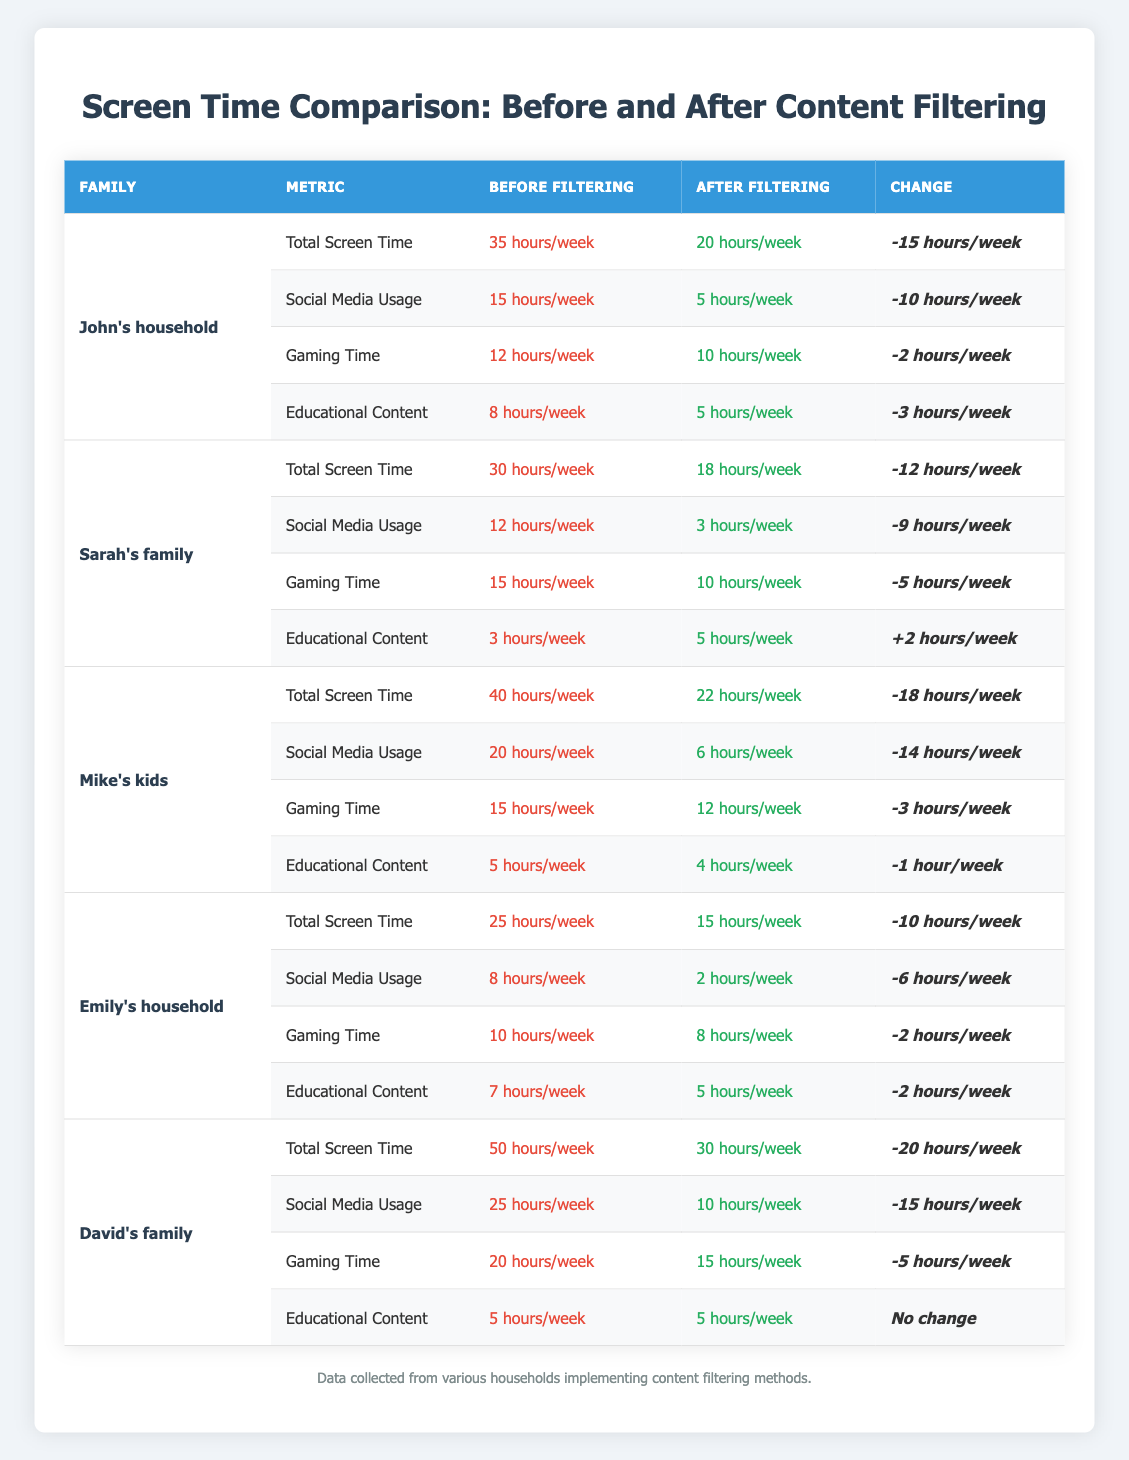What was the total screen time for John's household before filtering? The table shows that John's household had a total screen time of 35 hours per week before filtering.
Answer: 35 hours/week How many hours did Sarah's family reduce in social media usage after filtering? Sarah's family reduced their social media usage from 12 hours per week to 3 hours per week, which is a reduction of 12 - 3 = 9 hours.
Answer: 9 hours/week Which household had the highest total screen time after filtering? After filtering, David's family had 30 hours of total screen time, which is the highest compared to other households' totals after filtering.
Answer: David's family Did Emily's household have an increase in educational content watch time after filtering? Emily's household had 7 hours of educational content before filtering which decreased to 5 hours after filtering, indicating a reduction, not an increase.
Answer: No What is the average total screen time for all households before filtering? The total screen times for each household before filtering are 35, 30, 40, 25, and 50 hours. Summing these gives 180 hours, and dividing by 5 households leads to an average of 180/5 = 36 hours.
Answer: 36 hours/week Which household experienced the largest absolute change in total screen time? The largest absolute change is from David's family, which decreased by 20 hours, going from 50 hours to 30 hours.
Answer: David's family How many households had a total screen time less than 25 hours after implementing filters? After filtering, Emily's household (15 hours) and Sarah's family (18 hours) had total screen times less than 25 hours, making it 2 households.
Answer: 2 households What was the total change in educational content for Mike's kids? Mike's kids had 5 hours of educational content before filtering and 4 hours after filtering, so the change is 5 - 4 = 1 hour decrease.
Answer: -1 hour/week Which household had the lowest total screen time before filtering? Emily's household had the lowest total screen time of 25 hours per week before filtering compared to others.
Answer: Emily's household What was the combined social media usage of all households before and after filtering? Before filtering: 15 (John) + 12 (Sarah) + 20 (Mike) + 8 (Emily) + 25 (David) = 80 hours. After filtering: 5 (John) + 3 (Sarah) + 6 (Mike) + 2 (Emily) + 10 (David) = 26 hours. Total before and after filtering is 80 + 26 = 106 hours.
Answer: 106 hours 